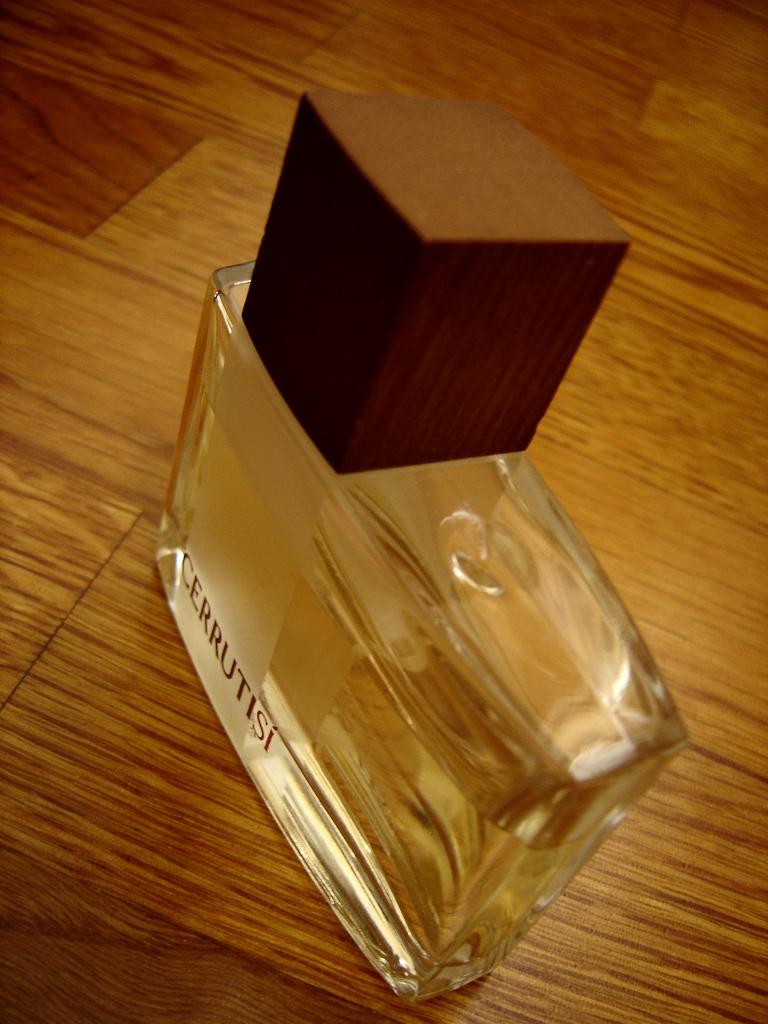What brand is this?
Keep it short and to the point. Cerrutisi. 